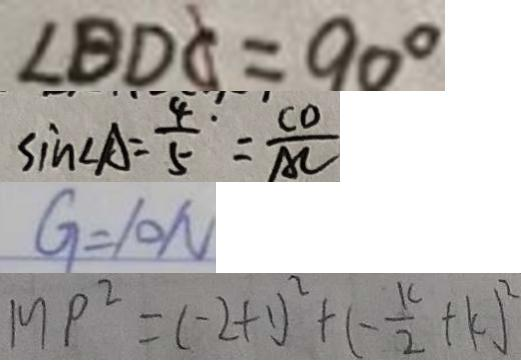<formula> <loc_0><loc_0><loc_500><loc_500>\angle B D C = 9 0 ^ { \circ } 
 \sin \angle A = \frac { 4 } { 5 } \cdot = \frac { C D } { A C } 
 G = 1 0 N 
 M P ^ { 2 } = ( - 2 + 1 ) ^ { 2 } + ( - \frac { k } { 2 } + k ) ^ { 2 }</formula> 